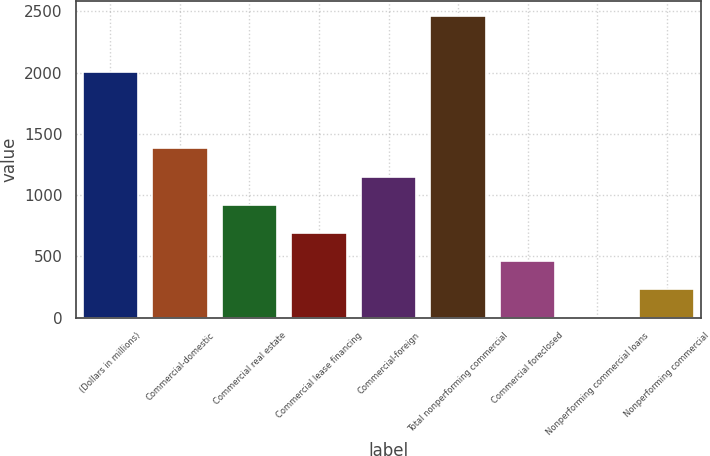Convert chart to OTSL. <chart><loc_0><loc_0><loc_500><loc_500><bar_chart><fcel>(Dollars in millions)<fcel>Commercial-domestic<fcel>Commercial real estate<fcel>Commercial lease financing<fcel>Commercial-foreign<fcel>Total nonperforming commercial<fcel>Commercial foreclosed<fcel>Nonperforming commercial loans<fcel>Nonperforming commercial<nl><fcel>2003<fcel>1388<fcel>921.82<fcel>691.79<fcel>1151.85<fcel>2465.03<fcel>461.76<fcel>1.7<fcel>231.73<nl></chart> 